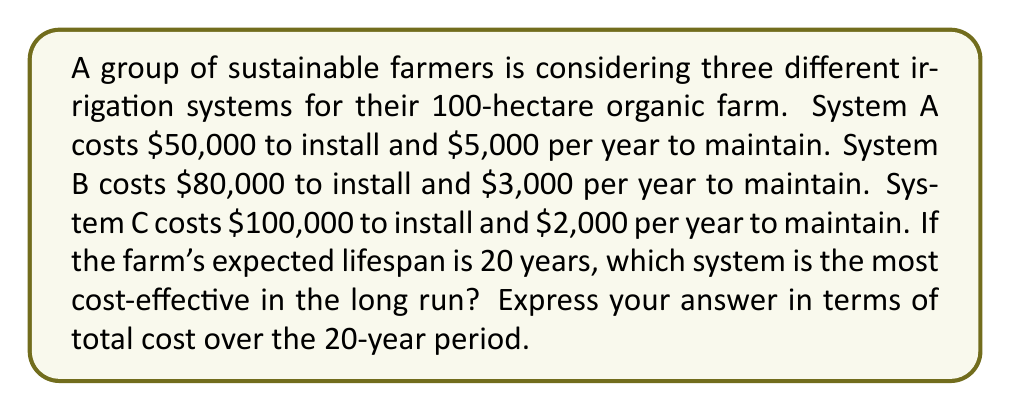Provide a solution to this math problem. To determine the most cost-effective irrigation system, we need to calculate the total cost for each system over the 20-year period.

1. For System A:
   Installation cost: $50,000
   Annual maintenance cost: $5,000
   Total maintenance cost over 20 years: $5,000 × 20 = $100,000
   Total cost: $50,000 + $100,000 = $150,000

2. For System B:
   Installation cost: $80,000
   Annual maintenance cost: $3,000
   Total maintenance cost over 20 years: $3,000 × 20 = $60,000
   Total cost: $80,000 + $60,000 = $140,000

3. For System C:
   Installation cost: $100,000
   Annual maintenance cost: $2,000
   Total maintenance cost over 20 years: $2,000 × 20 = $40,000
   Total cost: $100,000 + $40,000 = $140,000

Comparing the total costs:
System A: $150,000
System B: $140,000
System C: $140,000

Both System B and System C have the same total cost of $140,000 over the 20-year period, which is lower than System A's total cost of $150,000.

Therefore, both System B and System C are equally cost-effective in the long run.
Answer: Systems B and C, both costing $140,000 over 20 years 